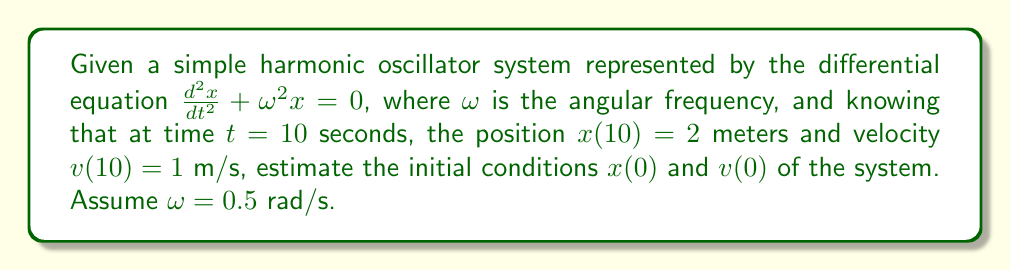Provide a solution to this math problem. 1. The general solution for a simple harmonic oscillator is:
   $x(t) = A \cos(\omega t) + B \sin(\omega t)$
   $v(t) = -A\omega \sin(\omega t) + B\omega \cos(\omega t)$

2. Given $\omega = 0.5$ rad/s, substitute the known values at $t=10$:
   $2 = A \cos(5) + B \sin(5)$
   $1 = -0.5A \sin(5) + 0.5B \cos(5)$

3. Solve this system of equations:
   $A \cos(5) + B \sin(5) = 2$
   $-A \sin(5) + B \cos(5) = 2$

4. Using matrix inversion:
   $$\begin{bmatrix} A \\ B \end{bmatrix} = \begin{bmatrix} \cos(5) & \sin(5) \\ -\sin(5) & \cos(5) \end{bmatrix}^{-1} \begin{bmatrix} 2 \\ 2 \end{bmatrix}$$

5. Solving this gives:
   $A \approx 2.8508$
   $B \approx 0.5403$

6. Now we have the full solution:
   $x(t) = 2.8508 \cos(0.5t) + 0.5403 \sin(0.5t)$
   $v(t) = -1.4254 \sin(0.5t) + 0.2702 \cos(0.5t)$

7. To find initial conditions, evaluate at $t=0$:
   $x(0) = 2.8508 \cos(0) + 0.5403 \sin(0) = 2.8508$
   $v(0) = -1.4254 \sin(0) + 0.2702 \cos(0) = 0.2702$
Answer: $x(0) \approx 2.8508$ m, $v(0) \approx 0.2702$ m/s 